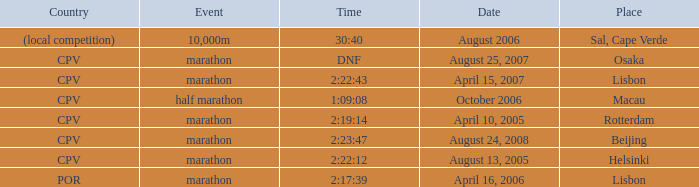What is the Place of the Event on August 25, 2007? Osaka. 